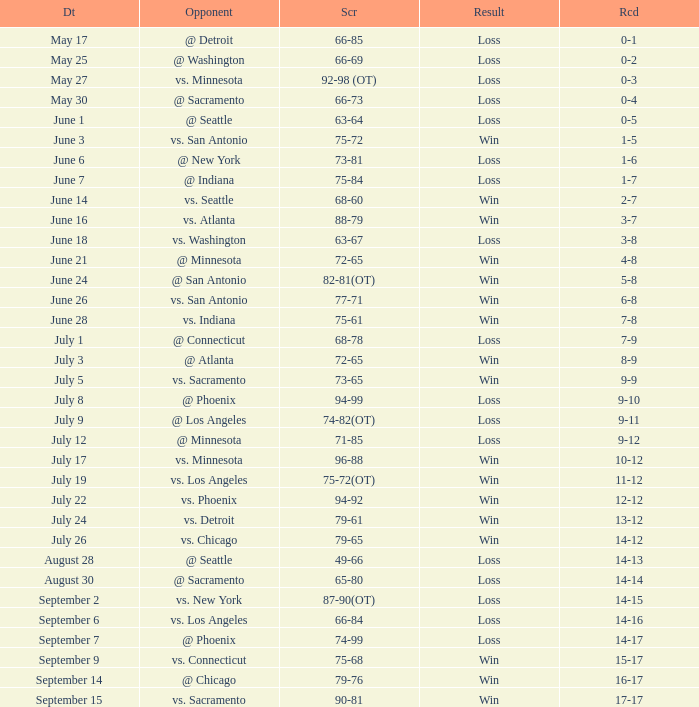What was the Result on May 30? Loss. 